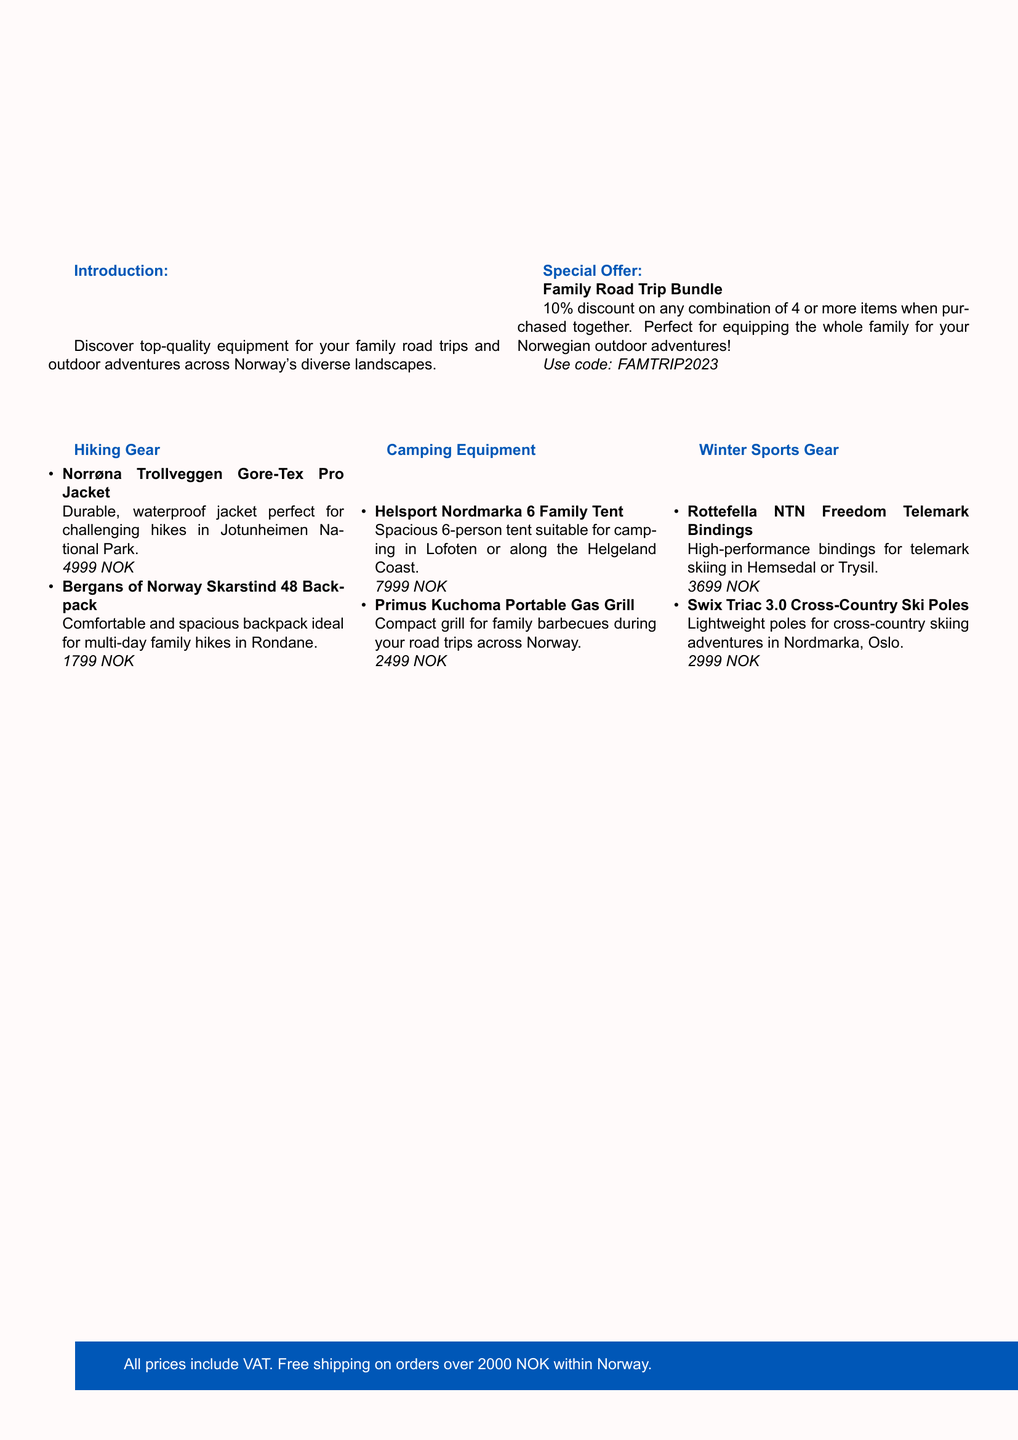What is the title of the catalog? The title is prominently displayed in the header section of the document.
Answer: Norwegian Adventure Essentials: Family-Friendly Outdoor Gear What is the discount percentage for the Family Road Trip Bundle? The discount percentage is mentioned in the special offer section of the document.
Answer: 10% How much is the Norrøna Trollveggen Gore-Tex Pro Jacket? The price of the jacket is listed in the hiking gear section of the document.
Answer: 4999 NOK Which tent is suitable for a 6-person family? The document mentions a specific tent designed for family use in the camping equipment section.
Answer: Helsport Nordmarka 6 Family Tent In which Norwegian location can the Rottefella NTN Freedom Telemark Bindings be used? The document states suitable locations for using the bindings in the winter sports gear section.
Answer: Hemsedal or Trysil What is the name of the portable grill listed in the catalog? The catalog lists the name of the grill in the camping equipment section.
Answer: Primus Kuchoma Portable Gas Grill What type of skiing are the Swix Triac 3.0 Cross-Country Ski Poles designed for? The suitability of the poles is explained in the winter sports gear section of the document.
Answer: Cross-country skiing What is the price of the Bergans of Norway Skarstind 48 Backpack? The backpack's price is provided in the hiking gear section of the document.
Answer: 1799 NOK 